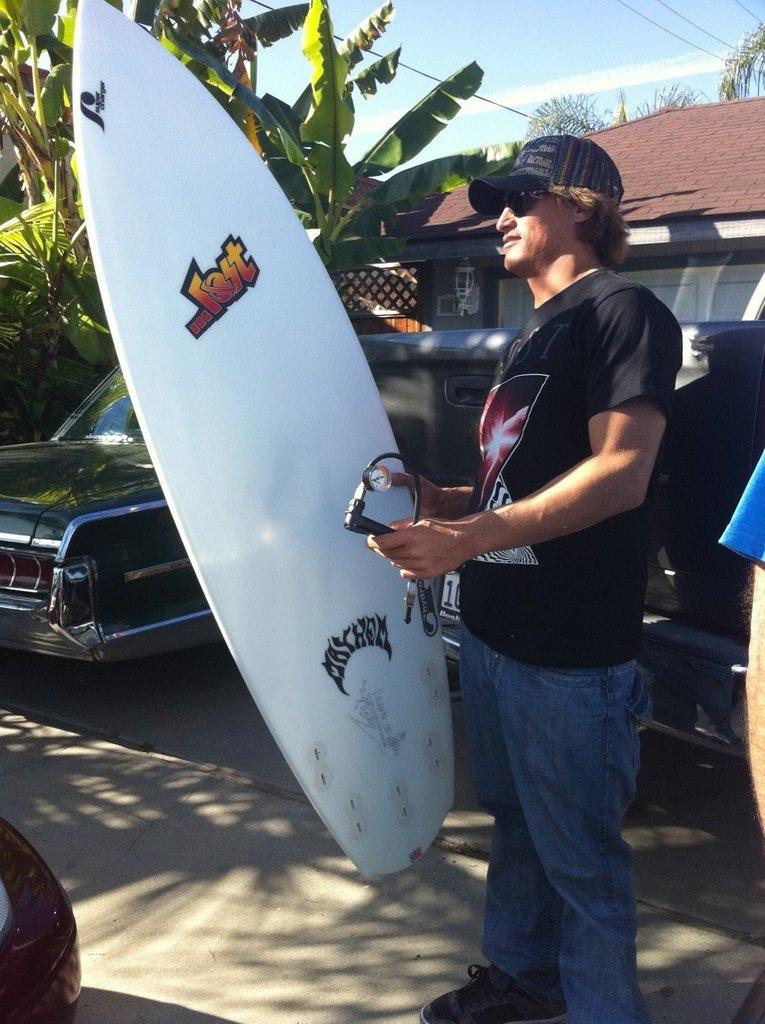What is the person in the image holding? The person is holding a surfboard. What can be seen in the background of the image? There are cars, a house, trees, and the sky visible in the background of the image. What type of activity might the person be preparing for? The person might be preparing for a surfing activity, given that they are holding a surfboard. What type of island can be seen in the image? There is no island present in the image. What kind of feast is being prepared in the image? There is no feast being prepared in the image. 